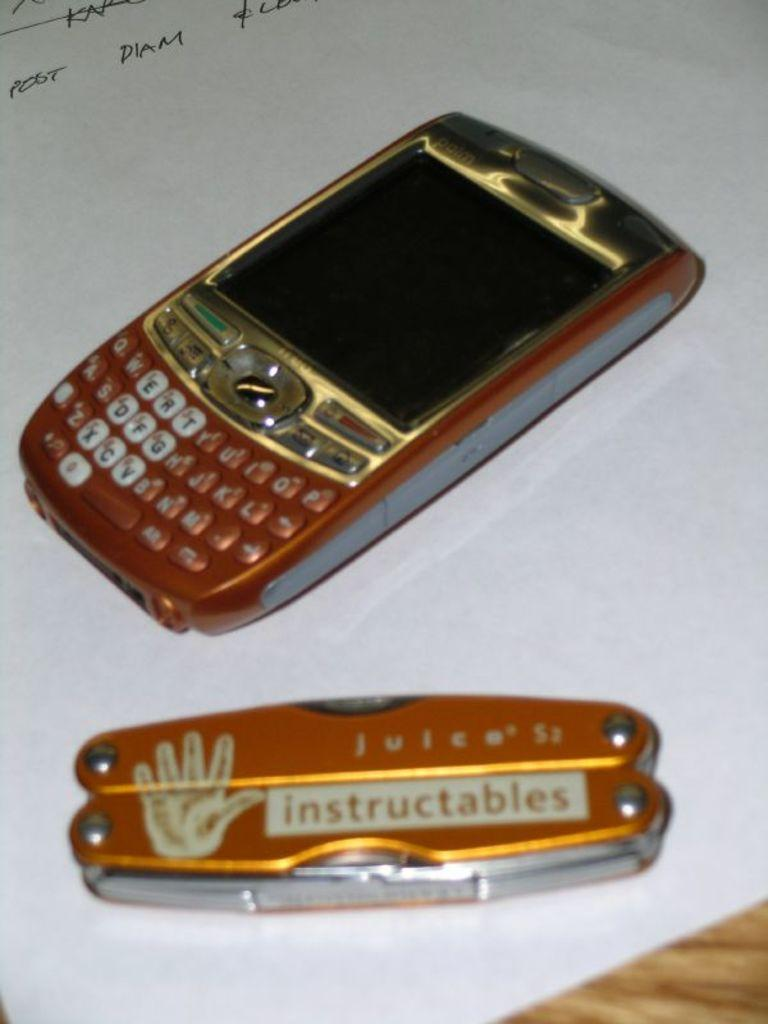<image>
Share a concise interpretation of the image provided. A pocket knife that says instructables has a picture of a hand on it. 